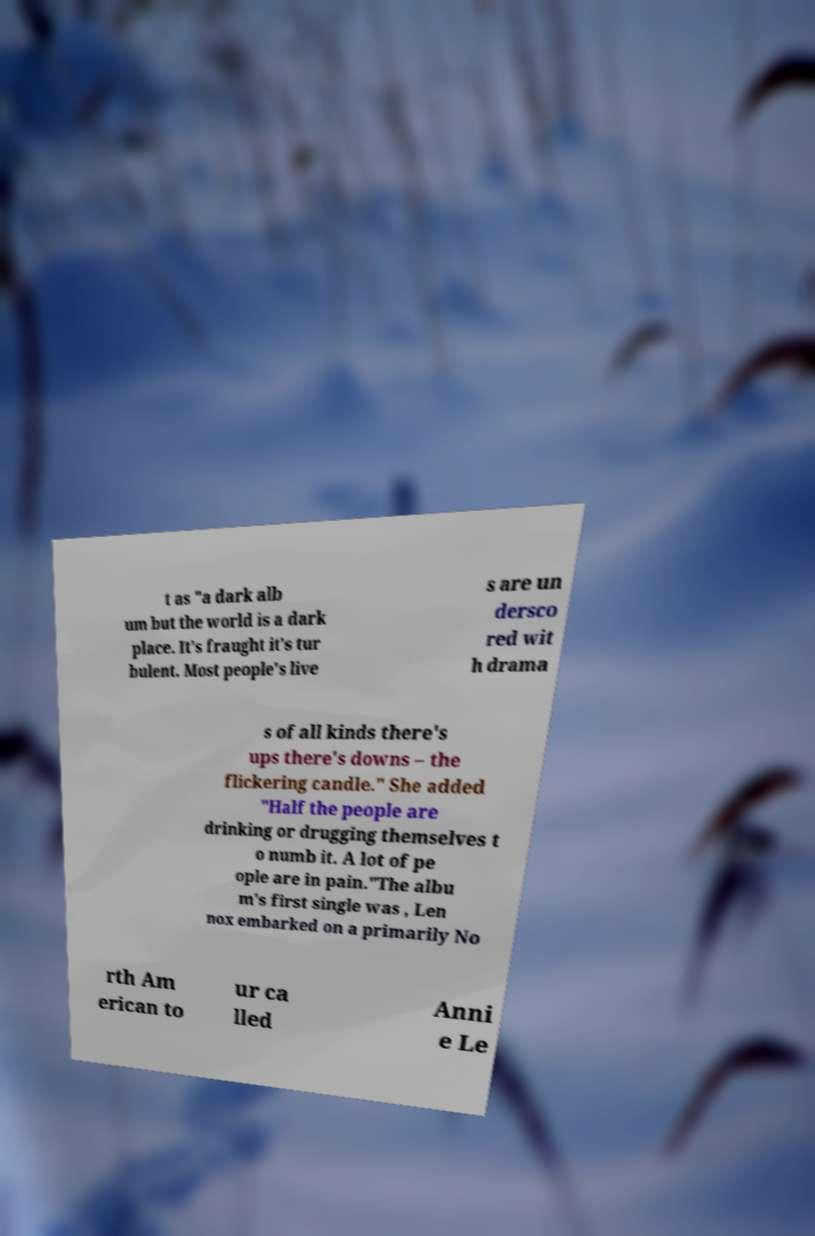For documentation purposes, I need the text within this image transcribed. Could you provide that? t as "a dark alb um but the world is a dark place. It's fraught it's tur bulent. Most people's live s are un dersco red wit h drama s of all kinds there's ups there's downs – the flickering candle." She added "Half the people are drinking or drugging themselves t o numb it. A lot of pe ople are in pain."The albu m's first single was , Len nox embarked on a primarily No rth Am erican to ur ca lled Anni e Le 